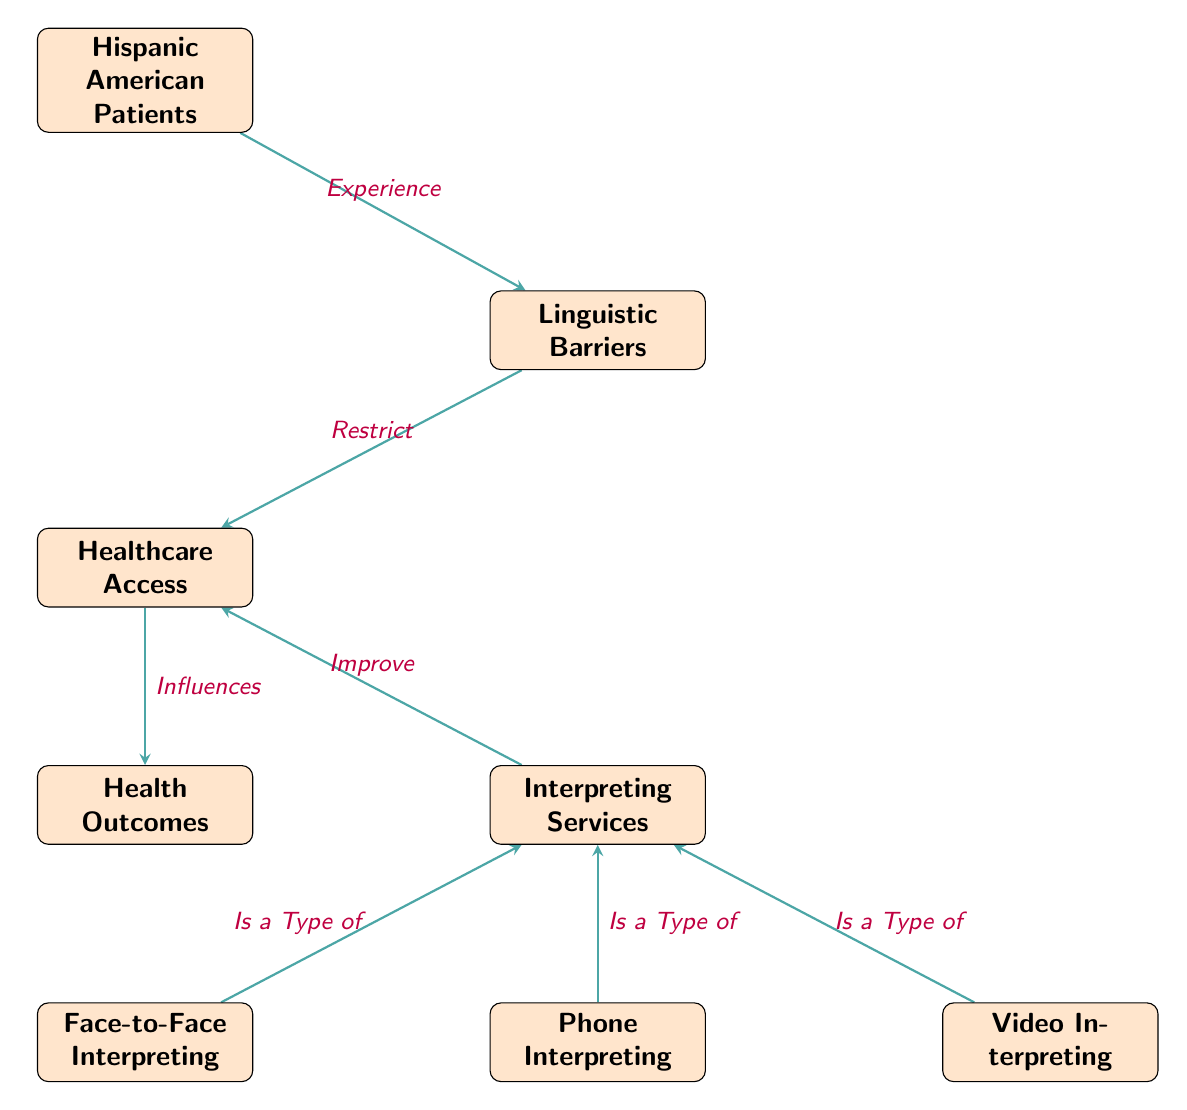What is the primary focus of this diagram? The diagram specifically illustrates the relationship between Hispanic American patients, linguistic barriers, and healthcare access. It shows how interpreting services can affect these elements.
Answer: Linguistic Barriers in Healthcare Access How many interpreting service types are listed in the diagram? There are three types listed: Face-to-Face Interpreting, Phone Interpreting, and Video Interpreting.
Answer: Three What relationship does the diagram present between access and outcomes? The diagram illustrates that access influences health outcomes, indicating a direct connection between these two concepts.
Answer: Influences What type of interpreting service is represented as a type of interpreting? The types of interpreting services are Face-to-Face Interpreting, Phone Interpreting, and Video Interpreting, all established as types.
Answer: Face-to-Face Interpreting Which entity restricts healthcare access? The diagram denotes that linguistic barriers restrict access to healthcare for Hispanic American patients.
Answer: Linguistic Barriers What is the effect of interpreting services on healthcare access? The diagram indicates that interpreting services improve access to healthcare, showing a positive relationship between them.
Answer: Improve How do Hispanic American patients experience linguistic barriers? The diagram shows that Hispanic American patients experience linguistic barriers as they seek healthcare, indicating a point of difficulty in access.
Answer: Experience What is the direction of influence from access to outcomes? The diagram shows that the arrow from access to outcomes points from access to outcomes, indicating that access has an influence on health outcomes.
Answer: Influences 